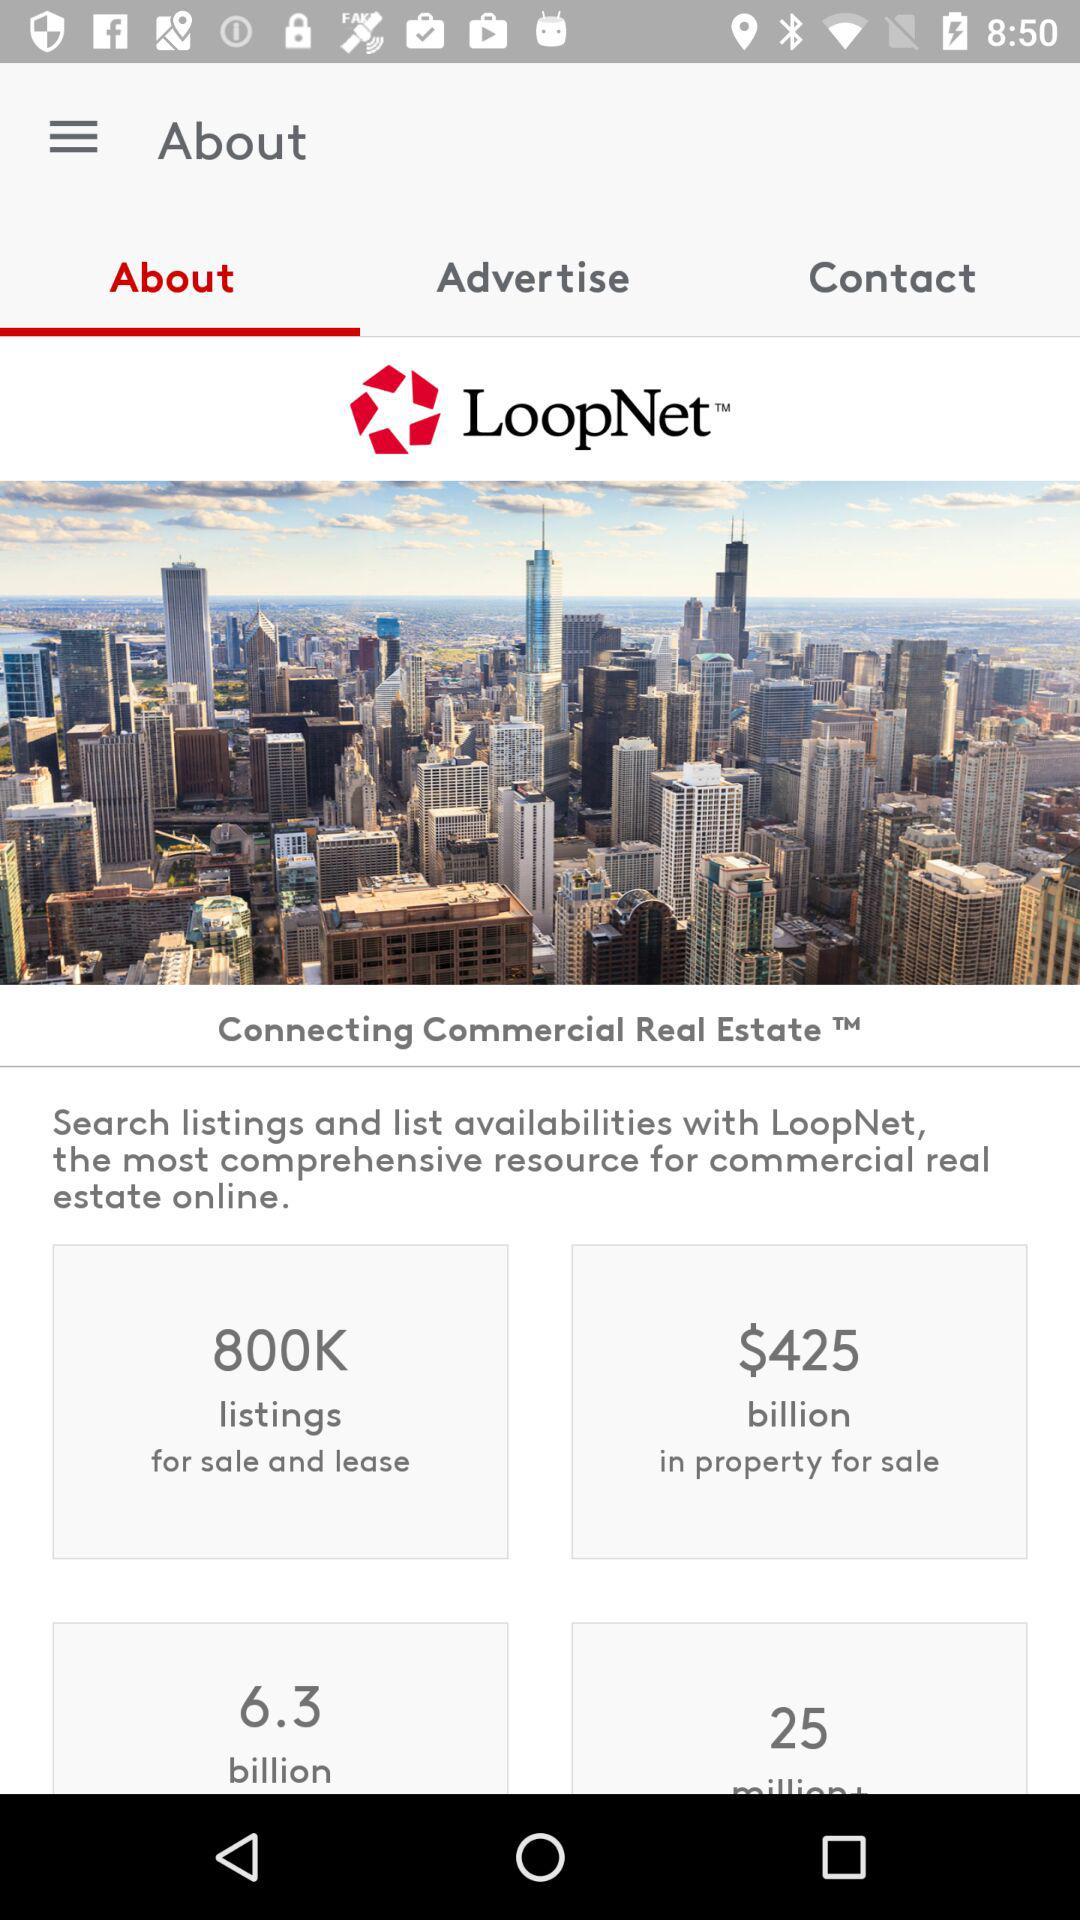How many properties are listed for sale and lease? The listed properties are 800K. 